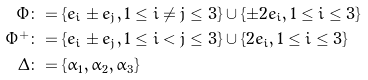<formula> <loc_0><loc_0><loc_500><loc_500>\Phi & \colon = \{ e _ { i } \pm e _ { j } , 1 \leq i \neq j \leq 3 \} \cup \{ \pm 2 e _ { i } , 1 \leq i \leq 3 \} \\ \Phi ^ { + } & \colon = \{ e _ { i } \pm e _ { j } , 1 \leq i < j \leq 3 \} \cup \{ 2 e _ { i } , 1 \leq i \leq 3 \} \\ \Delta & \colon = \{ \alpha _ { 1 } , \alpha _ { 2 } , \alpha _ { 3 } \}</formula> 